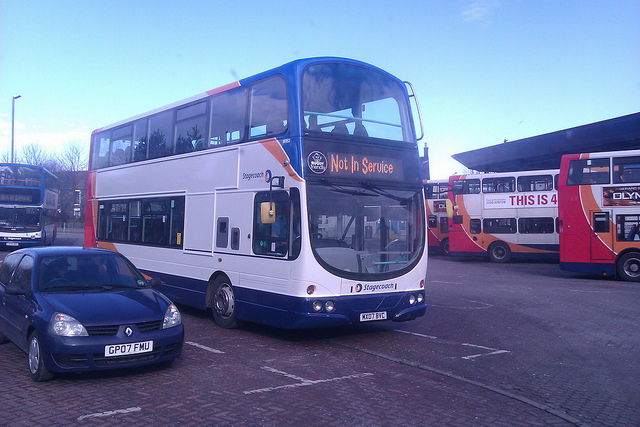Read and extract the text from this image. Not In Service THIS IS OLY 4 FMU GPO7 